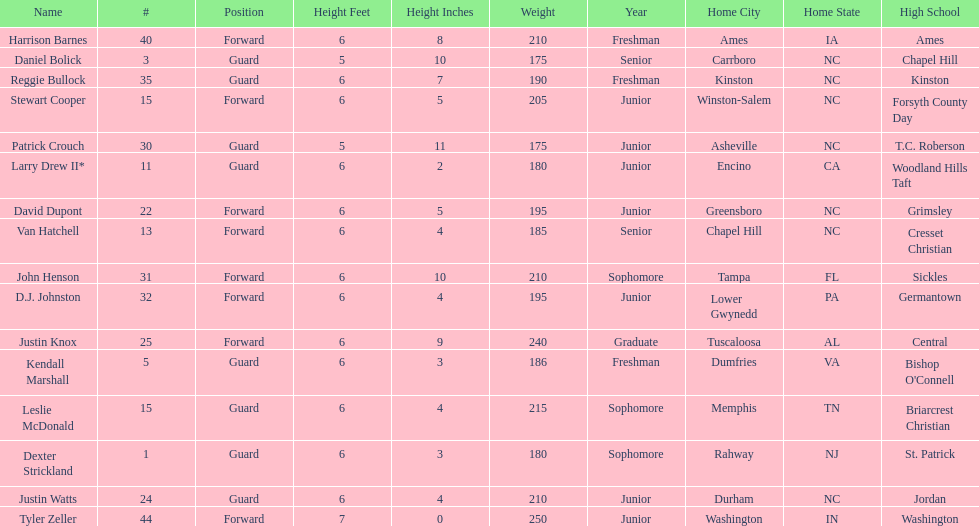What is the number of players with a weight over 200? 7. 